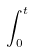<formula> <loc_0><loc_0><loc_500><loc_500>\int _ { 0 } ^ { t }</formula> 